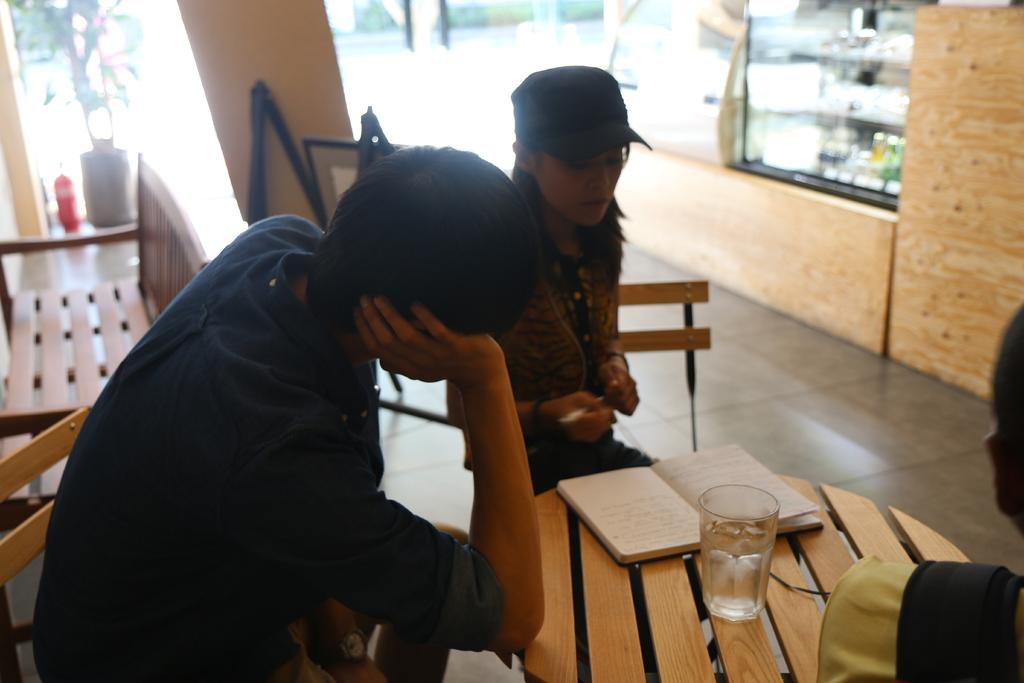How many people are in the image? There are two people in the image. What are the people doing in the image? The people are sitting on chairs. Where are the chairs located in relation to the table? The chairs are in front of a table. What objects can be seen on the table? There is a glass and a book on the table. Is there another chair visible in the image? Yes, there is another chair behind the people. Can you tell me what type of linen is draped over the chairs in the image? There is no linen draped over the chairs in the image. Is there any water visible in the image? There is no water visible in the image. 